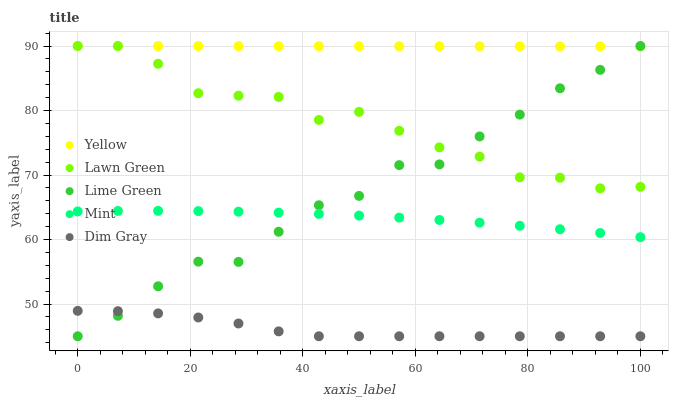Does Dim Gray have the minimum area under the curve?
Answer yes or no. Yes. Does Yellow have the maximum area under the curve?
Answer yes or no. Yes. Does Lime Green have the minimum area under the curve?
Answer yes or no. No. Does Lime Green have the maximum area under the curve?
Answer yes or no. No. Is Yellow the smoothest?
Answer yes or no. Yes. Is Lawn Green the roughest?
Answer yes or no. Yes. Is Dim Gray the smoothest?
Answer yes or no. No. Is Dim Gray the roughest?
Answer yes or no. No. Does Dim Gray have the lowest value?
Answer yes or no. Yes. Does Mint have the lowest value?
Answer yes or no. No. Does Yellow have the highest value?
Answer yes or no. Yes. Does Dim Gray have the highest value?
Answer yes or no. No. Is Dim Gray less than Mint?
Answer yes or no. Yes. Is Lawn Green greater than Dim Gray?
Answer yes or no. Yes. Does Mint intersect Lime Green?
Answer yes or no. Yes. Is Mint less than Lime Green?
Answer yes or no. No. Is Mint greater than Lime Green?
Answer yes or no. No. Does Dim Gray intersect Mint?
Answer yes or no. No. 